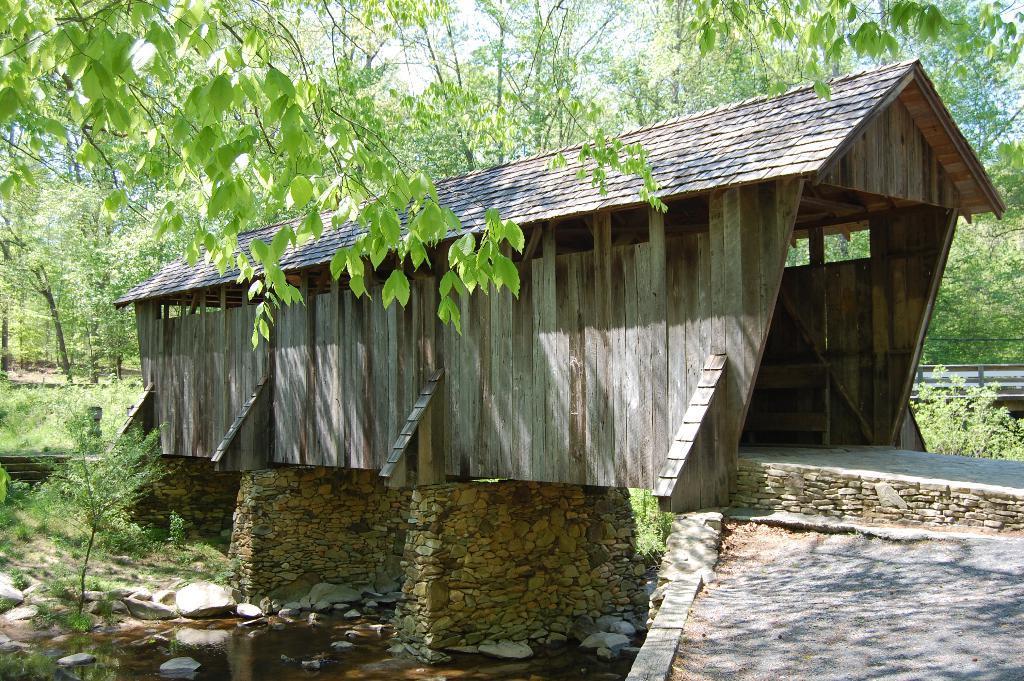Describe this image in one or two sentences. In this image I see a shark over here and I see the water and I see stones. In the background I see the trees and plants and I see the path over here. 